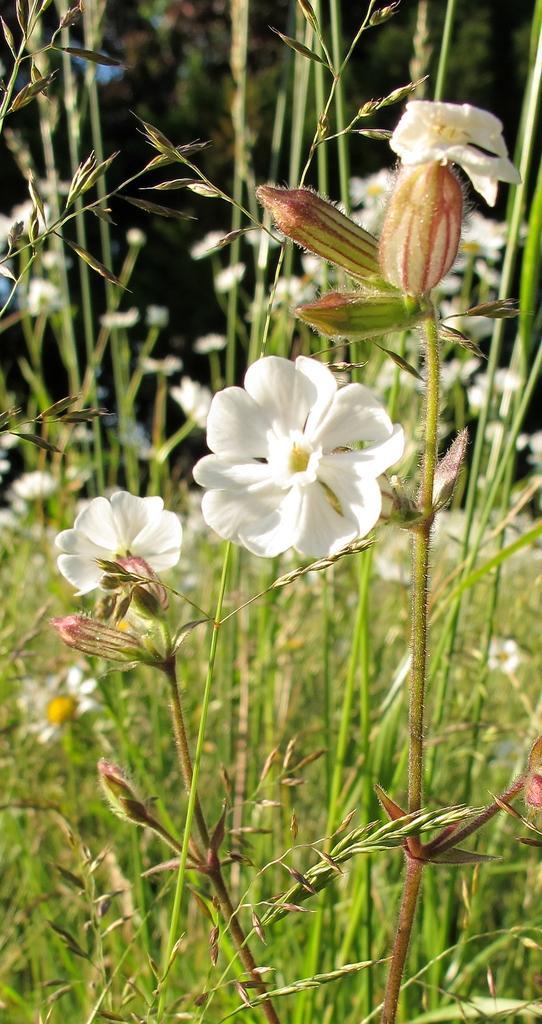Could you give a brief overview of what you see in this image? In this image I can see there are plants with flowers. And at the back there are trees. 